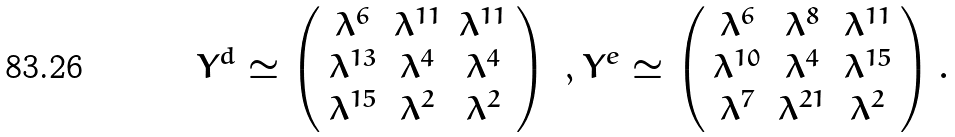<formula> <loc_0><loc_0><loc_500><loc_500>Y ^ { d } \simeq \left ( \begin{array} { c c c } \lambda ^ { 6 } & \lambda ^ { 1 1 } & \lambda ^ { 1 1 } \\ \lambda ^ { 1 3 } & \lambda ^ { 4 } & \lambda ^ { 4 } \\ \lambda ^ { 1 5 } & \lambda ^ { 2 } & \lambda ^ { 2 } \end{array} \right ) \ , Y ^ { e } \simeq \left ( \begin{array} { c c c } \lambda ^ { 6 } & \lambda ^ { 8 } & \lambda ^ { 1 1 } \\ \lambda ^ { 1 0 } & \lambda ^ { 4 } & \lambda ^ { 1 5 } \\ \lambda ^ { 7 } & \lambda ^ { 2 1 } & \lambda ^ { 2 } \end{array} \right ) .</formula> 